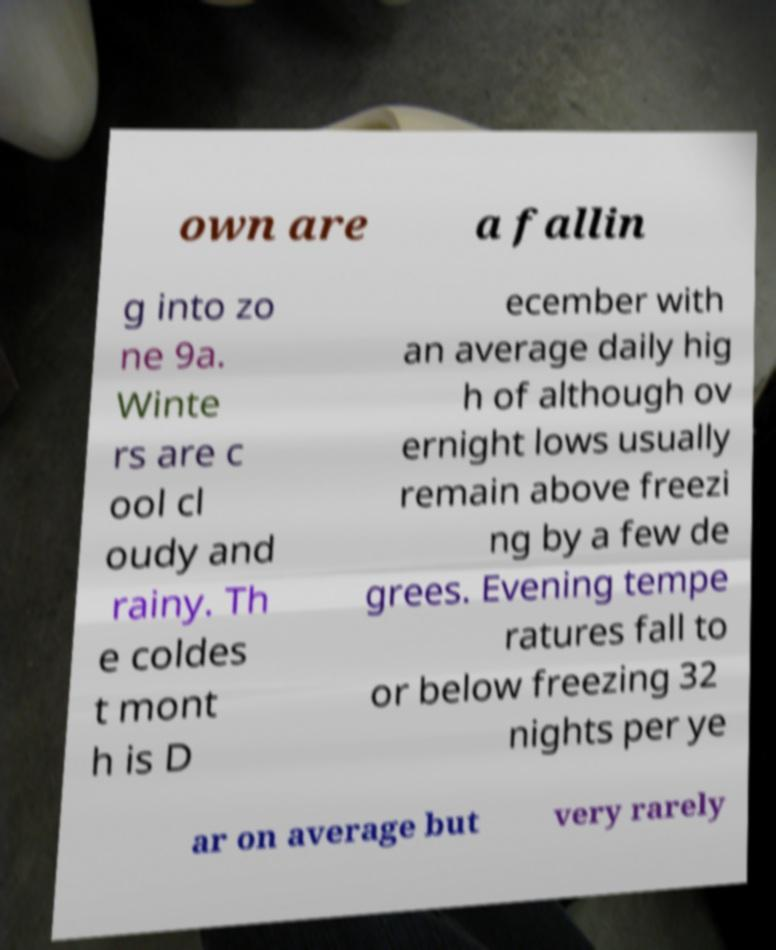Could you assist in decoding the text presented in this image and type it out clearly? own are a fallin g into zo ne 9a. Winte rs are c ool cl oudy and rainy. Th e coldes t mont h is D ecember with an average daily hig h of although ov ernight lows usually remain above freezi ng by a few de grees. Evening tempe ratures fall to or below freezing 32 nights per ye ar on average but very rarely 